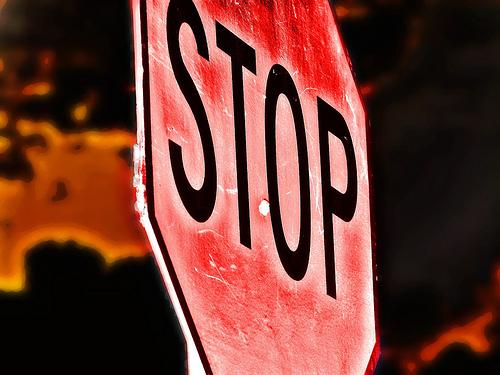Give a brief description of the occurrences in the image. A worn red and black stop sign with large letters has many scratches, a big hole, and a black and orange background surrounding it. Create a vivid description of the image as if you were describing it to someone who can't see it. Imagine a worn, neon-colored stop sign with large, bold letters spelling out "STOP" in black. The sign has endured some damage, as evidenced by numerous scratches and a sizable hole. The background is a mix of red, orange, and black. Describe the overall appearance and condition of the stop sign in the image. The neon-colored stop sign appears worn and damaged, with bold black letters spelling "STOP," surrounded by a background of red, orange, and black colors, and covered in multiple scratches and a large hole. Write a sentence that highlights the main theme of the image. The image features a vivid, battered stop sign with predominantly red and black colors, boldly displaying "STOP" in thick letters. Mention the key elements you see in the image and their relative positions. A stop sign with large, thick, black letters S, T, O, and P are positioned at the top-left, top-right, bottom-left, and bottom-right, respectively. There is a black and orange background with scratches and a hole on the sign. Explain what kind of sign you see in the image and what are the relevant features. The image portrays a neon-colored stop sign with a red, orange, and black background, large thick letters, and multiple scratches and a large hole on its surface. Provide a concise description of the primary object in the image. A red and black stop sign has large, thick letters spelling "STOP" and is covered in scratches, with a sizeable hole and black and orange coloring. Explain the main parts of the stop sign image and their colors. A red stop sign with a black border displays large, thick, black letters spelling "STOP." The background includes black, red, and orange colors, with the sign displaying several scratches on its surface. Point out the most noticeable aspects of the image. A scratched and damaged stop sign with thick black letters, a red and black color scheme, and a large hole on its surface stands out in the image. Summarize the image focusing on the main object and its features. A neon stop sign with large black letters is surrounded by a red, orange, and black background and covered with scratches and a hole in its surface. 